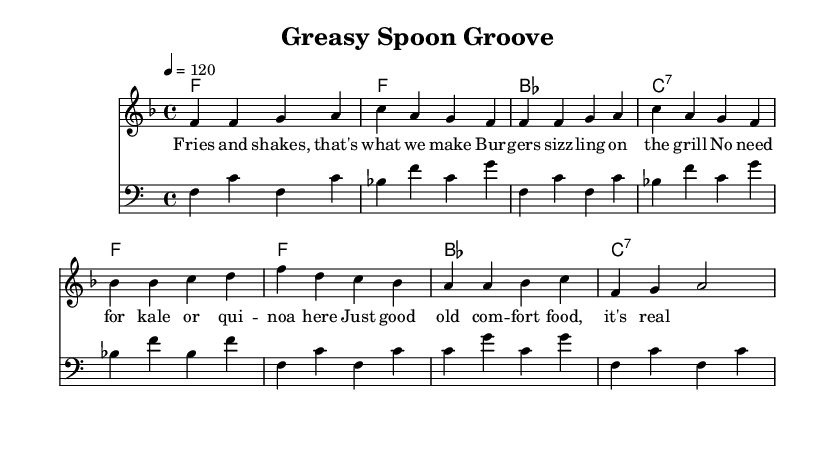What is the key signature of this music? The key signature is F major, which has one flat (B flat) as indicated at the beginning of the sheet music.
Answer: F major What is the time signature of this piece? The time signature shown at the beginning of the score is 4/4, indicating four beats in each measure.
Answer: 4/4 What is the tempo marking for this piece? The tempo marking indicates a speed of 120 beats per minute, which is represented in the score as "4 = 120".
Answer: 120 How many measures are in the melody section? The melody section has eight measures, which can be counted when viewing the score as each line of the melody consists of four bars, with two lines in total.
Answer: Eight What is the first lyric line of the song? The first lyric line provided in the score is “Fries and shakes, that's what we make”, clearly showing the words above the corresponding melody notes.
Answer: Fries and shakes, that's what we make Which chord follows the bass line of the first measure? The chord following the bass line of the first measure is F, as indicated by the chord symbols above the staff in the score.
Answer: F What type of food is celebrated in this song? The song celebrates traditional comfort food, as emphasized in the lyrics such as "Burgers sizzling on the grill" indicating a focus on hearty, classic American dishes.
Answer: Comfort food 